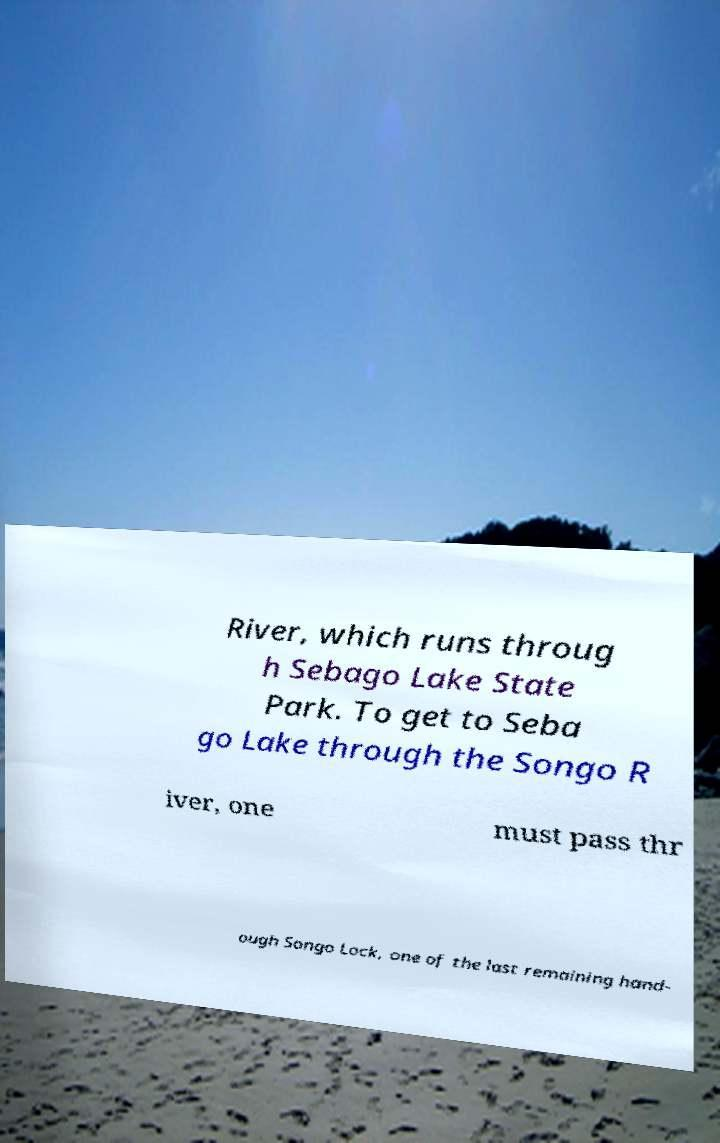What messages or text are displayed in this image? I need them in a readable, typed format. River, which runs throug h Sebago Lake State Park. To get to Seba go Lake through the Songo R iver, one must pass thr ough Songo Lock, one of the last remaining hand- 